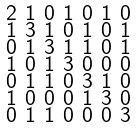<formula> <loc_0><loc_0><loc_500><loc_500>\begin{smallmatrix} 2 & 1 & 0 & 1 & 0 & 1 & 0 \\ 1 & 3 & 1 & 0 & 1 & 0 & 1 \\ 0 & 1 & 3 & 1 & 1 & 0 & 1 \\ 1 & 0 & 1 & 3 & 0 & 0 & 0 \\ 0 & 1 & 1 & 0 & 3 & 1 & 0 \\ 1 & 0 & 0 & 0 & 1 & 3 & 0 \\ 0 & 1 & 1 & 0 & 0 & 0 & 3 \end{smallmatrix}</formula> 